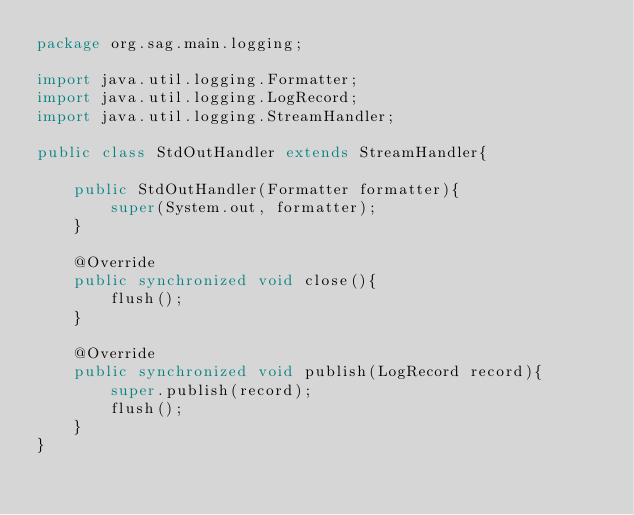Convert code to text. <code><loc_0><loc_0><loc_500><loc_500><_Java_>package org.sag.main.logging;

import java.util.logging.Formatter;
import java.util.logging.LogRecord;
import java.util.logging.StreamHandler;

public class StdOutHandler extends StreamHandler{

	public StdOutHandler(Formatter formatter){
		super(System.out, formatter);
	}
	
	@Override
	public synchronized void close(){
		flush();
	}
	
	@Override
	public synchronized void publish(LogRecord record){
		super.publish(record);
		flush();
	}
}
</code> 